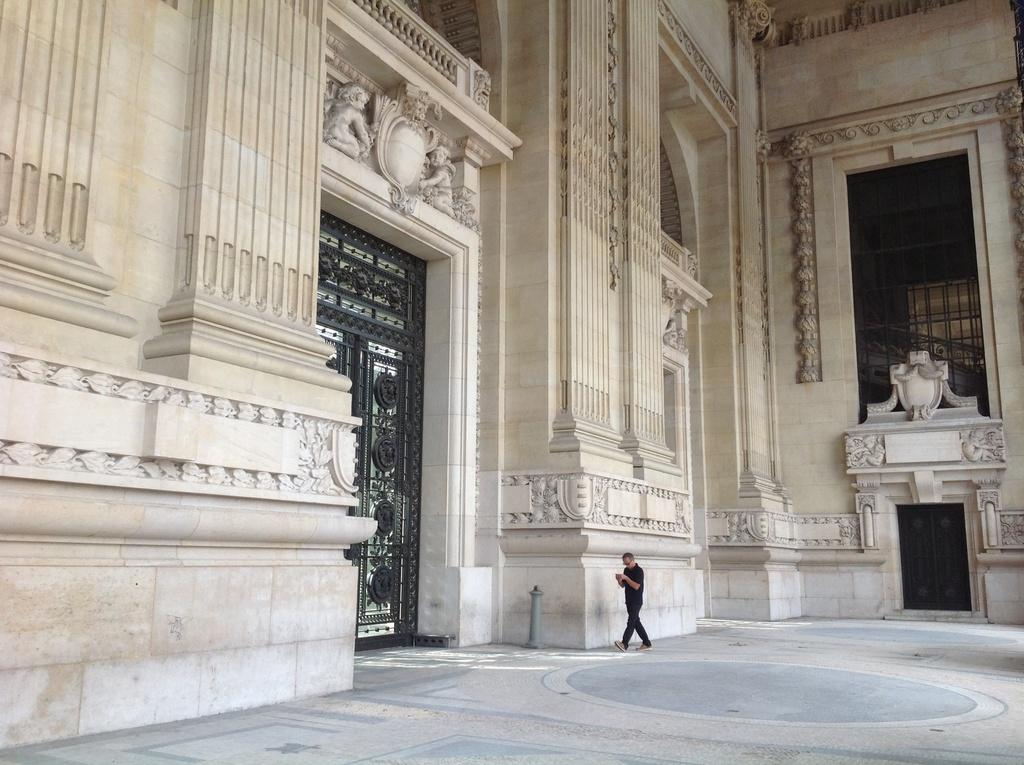What type of structure is present in the image? There is a building in the image. Can you describe any activity taking place in the image? There is a person walking in the image. What time is the meeting scheduled for in the image? There is no meeting or clock present in the image, so it is not possible to determine the time of a meeting. 